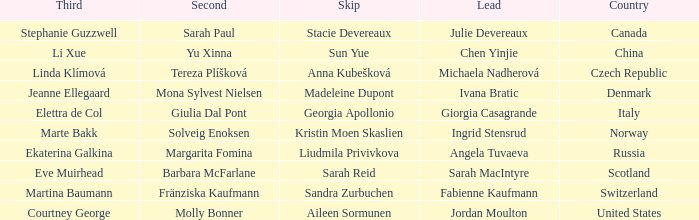What skip has switzerland as the country? Sandra Zurbuchen. 